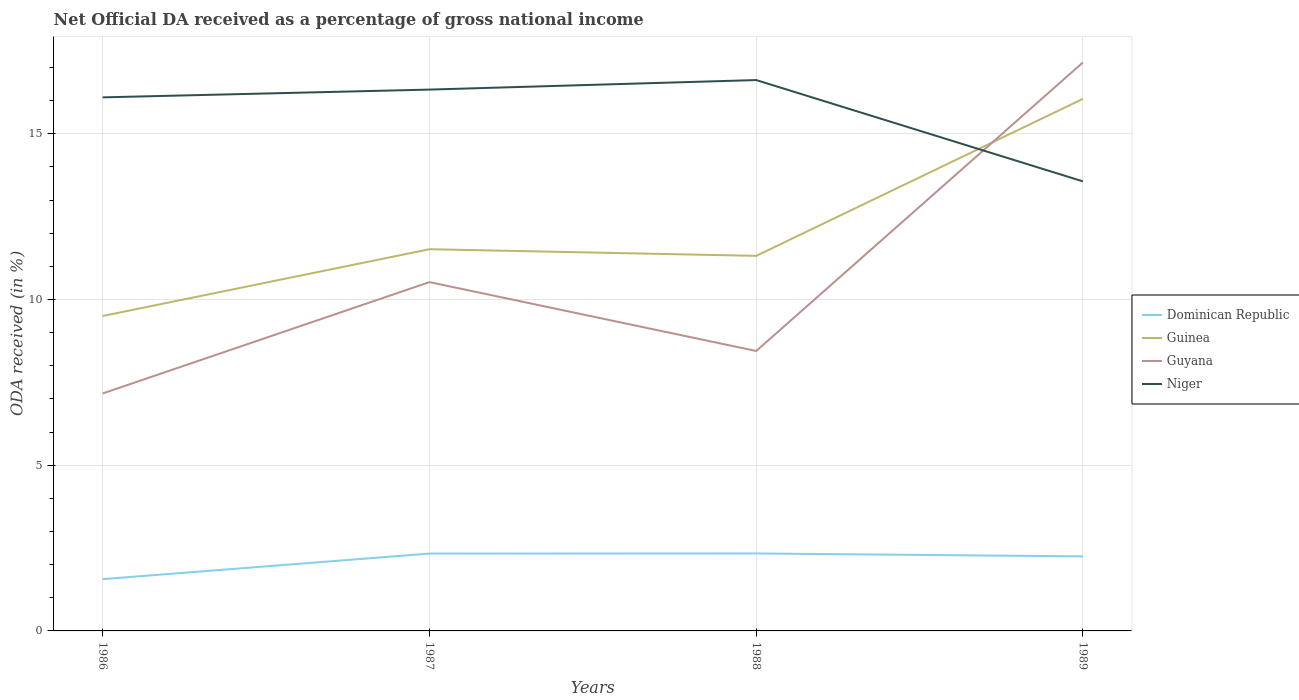How many different coloured lines are there?
Offer a very short reply. 4. Across all years, what is the maximum net official DA received in Niger?
Give a very brief answer. 13.56. In which year was the net official DA received in Guinea maximum?
Provide a succinct answer. 1986. What is the total net official DA received in Guyana in the graph?
Offer a terse response. -9.99. What is the difference between the highest and the second highest net official DA received in Niger?
Your answer should be very brief. 3.06. How many lines are there?
Keep it short and to the point. 4. What is the difference between two consecutive major ticks on the Y-axis?
Offer a very short reply. 5. Does the graph contain grids?
Offer a terse response. Yes. How many legend labels are there?
Make the answer very short. 4. What is the title of the graph?
Offer a very short reply. Net Official DA received as a percentage of gross national income. Does "Swaziland" appear as one of the legend labels in the graph?
Provide a succinct answer. No. What is the label or title of the X-axis?
Give a very brief answer. Years. What is the label or title of the Y-axis?
Your answer should be very brief. ODA received (in %). What is the ODA received (in %) in Dominican Republic in 1986?
Provide a succinct answer. 1.56. What is the ODA received (in %) of Guinea in 1986?
Provide a succinct answer. 9.5. What is the ODA received (in %) of Guyana in 1986?
Make the answer very short. 7.17. What is the ODA received (in %) in Niger in 1986?
Give a very brief answer. 16.1. What is the ODA received (in %) in Dominican Republic in 1987?
Your answer should be very brief. 2.33. What is the ODA received (in %) in Guinea in 1987?
Offer a terse response. 11.52. What is the ODA received (in %) of Guyana in 1987?
Offer a very short reply. 10.52. What is the ODA received (in %) of Niger in 1987?
Your response must be concise. 16.33. What is the ODA received (in %) of Dominican Republic in 1988?
Make the answer very short. 2.34. What is the ODA received (in %) of Guinea in 1988?
Make the answer very short. 11.32. What is the ODA received (in %) in Guyana in 1988?
Your answer should be very brief. 8.45. What is the ODA received (in %) in Niger in 1988?
Your response must be concise. 16.62. What is the ODA received (in %) of Dominican Republic in 1989?
Your response must be concise. 2.25. What is the ODA received (in %) of Guinea in 1989?
Give a very brief answer. 16.05. What is the ODA received (in %) in Guyana in 1989?
Offer a terse response. 17.15. What is the ODA received (in %) in Niger in 1989?
Your answer should be very brief. 13.56. Across all years, what is the maximum ODA received (in %) of Dominican Republic?
Your answer should be very brief. 2.34. Across all years, what is the maximum ODA received (in %) in Guinea?
Your response must be concise. 16.05. Across all years, what is the maximum ODA received (in %) of Guyana?
Provide a succinct answer. 17.15. Across all years, what is the maximum ODA received (in %) in Niger?
Provide a succinct answer. 16.62. Across all years, what is the minimum ODA received (in %) of Dominican Republic?
Your answer should be compact. 1.56. Across all years, what is the minimum ODA received (in %) of Guinea?
Your answer should be compact. 9.5. Across all years, what is the minimum ODA received (in %) of Guyana?
Provide a succinct answer. 7.17. Across all years, what is the minimum ODA received (in %) of Niger?
Provide a short and direct response. 13.56. What is the total ODA received (in %) in Dominican Republic in the graph?
Keep it short and to the point. 8.48. What is the total ODA received (in %) in Guinea in the graph?
Provide a succinct answer. 48.39. What is the total ODA received (in %) of Guyana in the graph?
Your answer should be very brief. 43.29. What is the total ODA received (in %) of Niger in the graph?
Ensure brevity in your answer.  62.61. What is the difference between the ODA received (in %) in Dominican Republic in 1986 and that in 1987?
Offer a very short reply. -0.77. What is the difference between the ODA received (in %) in Guinea in 1986 and that in 1987?
Your answer should be compact. -2.01. What is the difference between the ODA received (in %) of Guyana in 1986 and that in 1987?
Provide a succinct answer. -3.36. What is the difference between the ODA received (in %) of Niger in 1986 and that in 1987?
Keep it short and to the point. -0.23. What is the difference between the ODA received (in %) in Dominican Republic in 1986 and that in 1988?
Ensure brevity in your answer.  -0.78. What is the difference between the ODA received (in %) in Guinea in 1986 and that in 1988?
Provide a short and direct response. -1.81. What is the difference between the ODA received (in %) in Guyana in 1986 and that in 1988?
Provide a short and direct response. -1.28. What is the difference between the ODA received (in %) in Niger in 1986 and that in 1988?
Keep it short and to the point. -0.52. What is the difference between the ODA received (in %) of Dominican Republic in 1986 and that in 1989?
Give a very brief answer. -0.69. What is the difference between the ODA received (in %) in Guinea in 1986 and that in 1989?
Your answer should be compact. -6.55. What is the difference between the ODA received (in %) of Guyana in 1986 and that in 1989?
Offer a terse response. -9.99. What is the difference between the ODA received (in %) in Niger in 1986 and that in 1989?
Your response must be concise. 2.53. What is the difference between the ODA received (in %) of Dominican Republic in 1987 and that in 1988?
Keep it short and to the point. -0. What is the difference between the ODA received (in %) in Guinea in 1987 and that in 1988?
Provide a short and direct response. 0.2. What is the difference between the ODA received (in %) of Guyana in 1987 and that in 1988?
Your answer should be compact. 2.08. What is the difference between the ODA received (in %) in Niger in 1987 and that in 1988?
Offer a very short reply. -0.29. What is the difference between the ODA received (in %) of Dominican Republic in 1987 and that in 1989?
Your answer should be compact. 0.08. What is the difference between the ODA received (in %) of Guinea in 1987 and that in 1989?
Your answer should be compact. -4.54. What is the difference between the ODA received (in %) in Guyana in 1987 and that in 1989?
Your answer should be compact. -6.63. What is the difference between the ODA received (in %) in Niger in 1987 and that in 1989?
Your response must be concise. 2.77. What is the difference between the ODA received (in %) of Dominican Republic in 1988 and that in 1989?
Ensure brevity in your answer.  0.09. What is the difference between the ODA received (in %) in Guinea in 1988 and that in 1989?
Offer a very short reply. -4.74. What is the difference between the ODA received (in %) in Guyana in 1988 and that in 1989?
Offer a very short reply. -8.71. What is the difference between the ODA received (in %) of Niger in 1988 and that in 1989?
Your response must be concise. 3.06. What is the difference between the ODA received (in %) in Dominican Republic in 1986 and the ODA received (in %) in Guinea in 1987?
Give a very brief answer. -9.95. What is the difference between the ODA received (in %) of Dominican Republic in 1986 and the ODA received (in %) of Guyana in 1987?
Give a very brief answer. -8.96. What is the difference between the ODA received (in %) in Dominican Republic in 1986 and the ODA received (in %) in Niger in 1987?
Your answer should be very brief. -14.77. What is the difference between the ODA received (in %) of Guinea in 1986 and the ODA received (in %) of Guyana in 1987?
Keep it short and to the point. -1.02. What is the difference between the ODA received (in %) of Guinea in 1986 and the ODA received (in %) of Niger in 1987?
Ensure brevity in your answer.  -6.83. What is the difference between the ODA received (in %) in Guyana in 1986 and the ODA received (in %) in Niger in 1987?
Offer a very short reply. -9.17. What is the difference between the ODA received (in %) of Dominican Republic in 1986 and the ODA received (in %) of Guinea in 1988?
Your answer should be very brief. -9.75. What is the difference between the ODA received (in %) of Dominican Republic in 1986 and the ODA received (in %) of Guyana in 1988?
Provide a succinct answer. -6.88. What is the difference between the ODA received (in %) in Dominican Republic in 1986 and the ODA received (in %) in Niger in 1988?
Offer a very short reply. -15.06. What is the difference between the ODA received (in %) of Guinea in 1986 and the ODA received (in %) of Guyana in 1988?
Offer a very short reply. 1.06. What is the difference between the ODA received (in %) in Guinea in 1986 and the ODA received (in %) in Niger in 1988?
Ensure brevity in your answer.  -7.12. What is the difference between the ODA received (in %) in Guyana in 1986 and the ODA received (in %) in Niger in 1988?
Offer a very short reply. -9.46. What is the difference between the ODA received (in %) in Dominican Republic in 1986 and the ODA received (in %) in Guinea in 1989?
Provide a succinct answer. -14.49. What is the difference between the ODA received (in %) of Dominican Republic in 1986 and the ODA received (in %) of Guyana in 1989?
Provide a short and direct response. -15.59. What is the difference between the ODA received (in %) in Dominican Republic in 1986 and the ODA received (in %) in Niger in 1989?
Offer a very short reply. -12. What is the difference between the ODA received (in %) of Guinea in 1986 and the ODA received (in %) of Guyana in 1989?
Provide a short and direct response. -7.65. What is the difference between the ODA received (in %) of Guinea in 1986 and the ODA received (in %) of Niger in 1989?
Make the answer very short. -4.06. What is the difference between the ODA received (in %) in Guyana in 1986 and the ODA received (in %) in Niger in 1989?
Provide a short and direct response. -6.4. What is the difference between the ODA received (in %) in Dominican Republic in 1987 and the ODA received (in %) in Guinea in 1988?
Ensure brevity in your answer.  -8.98. What is the difference between the ODA received (in %) of Dominican Republic in 1987 and the ODA received (in %) of Guyana in 1988?
Make the answer very short. -6.11. What is the difference between the ODA received (in %) of Dominican Republic in 1987 and the ODA received (in %) of Niger in 1988?
Your answer should be compact. -14.29. What is the difference between the ODA received (in %) in Guinea in 1987 and the ODA received (in %) in Guyana in 1988?
Keep it short and to the point. 3.07. What is the difference between the ODA received (in %) in Guinea in 1987 and the ODA received (in %) in Niger in 1988?
Your response must be concise. -5.1. What is the difference between the ODA received (in %) of Guyana in 1987 and the ODA received (in %) of Niger in 1988?
Keep it short and to the point. -6.1. What is the difference between the ODA received (in %) in Dominican Republic in 1987 and the ODA received (in %) in Guinea in 1989?
Your response must be concise. -13.72. What is the difference between the ODA received (in %) in Dominican Republic in 1987 and the ODA received (in %) in Guyana in 1989?
Provide a succinct answer. -14.82. What is the difference between the ODA received (in %) in Dominican Republic in 1987 and the ODA received (in %) in Niger in 1989?
Your answer should be compact. -11.23. What is the difference between the ODA received (in %) in Guinea in 1987 and the ODA received (in %) in Guyana in 1989?
Your answer should be compact. -5.64. What is the difference between the ODA received (in %) of Guinea in 1987 and the ODA received (in %) of Niger in 1989?
Provide a short and direct response. -2.05. What is the difference between the ODA received (in %) in Guyana in 1987 and the ODA received (in %) in Niger in 1989?
Make the answer very short. -3.04. What is the difference between the ODA received (in %) in Dominican Republic in 1988 and the ODA received (in %) in Guinea in 1989?
Offer a terse response. -13.72. What is the difference between the ODA received (in %) of Dominican Republic in 1988 and the ODA received (in %) of Guyana in 1989?
Provide a short and direct response. -14.82. What is the difference between the ODA received (in %) in Dominican Republic in 1988 and the ODA received (in %) in Niger in 1989?
Your answer should be compact. -11.23. What is the difference between the ODA received (in %) of Guinea in 1988 and the ODA received (in %) of Guyana in 1989?
Give a very brief answer. -5.84. What is the difference between the ODA received (in %) of Guinea in 1988 and the ODA received (in %) of Niger in 1989?
Ensure brevity in your answer.  -2.25. What is the difference between the ODA received (in %) in Guyana in 1988 and the ODA received (in %) in Niger in 1989?
Make the answer very short. -5.12. What is the average ODA received (in %) of Dominican Republic per year?
Provide a short and direct response. 2.12. What is the average ODA received (in %) of Guinea per year?
Ensure brevity in your answer.  12.1. What is the average ODA received (in %) in Guyana per year?
Offer a terse response. 10.82. What is the average ODA received (in %) of Niger per year?
Provide a succinct answer. 15.65. In the year 1986, what is the difference between the ODA received (in %) of Dominican Republic and ODA received (in %) of Guinea?
Your response must be concise. -7.94. In the year 1986, what is the difference between the ODA received (in %) of Dominican Republic and ODA received (in %) of Guyana?
Give a very brief answer. -5.6. In the year 1986, what is the difference between the ODA received (in %) of Dominican Republic and ODA received (in %) of Niger?
Your answer should be compact. -14.54. In the year 1986, what is the difference between the ODA received (in %) in Guinea and ODA received (in %) in Guyana?
Your answer should be compact. 2.34. In the year 1986, what is the difference between the ODA received (in %) in Guinea and ODA received (in %) in Niger?
Make the answer very short. -6.6. In the year 1986, what is the difference between the ODA received (in %) in Guyana and ODA received (in %) in Niger?
Give a very brief answer. -8.93. In the year 1987, what is the difference between the ODA received (in %) of Dominican Republic and ODA received (in %) of Guinea?
Ensure brevity in your answer.  -9.18. In the year 1987, what is the difference between the ODA received (in %) in Dominican Republic and ODA received (in %) in Guyana?
Keep it short and to the point. -8.19. In the year 1987, what is the difference between the ODA received (in %) of Dominican Republic and ODA received (in %) of Niger?
Your answer should be very brief. -14. In the year 1987, what is the difference between the ODA received (in %) in Guinea and ODA received (in %) in Niger?
Offer a very short reply. -4.82. In the year 1987, what is the difference between the ODA received (in %) in Guyana and ODA received (in %) in Niger?
Offer a terse response. -5.81. In the year 1988, what is the difference between the ODA received (in %) of Dominican Republic and ODA received (in %) of Guinea?
Your response must be concise. -8.98. In the year 1988, what is the difference between the ODA received (in %) in Dominican Republic and ODA received (in %) in Guyana?
Give a very brief answer. -6.11. In the year 1988, what is the difference between the ODA received (in %) in Dominican Republic and ODA received (in %) in Niger?
Offer a terse response. -14.28. In the year 1988, what is the difference between the ODA received (in %) in Guinea and ODA received (in %) in Guyana?
Your answer should be compact. 2.87. In the year 1988, what is the difference between the ODA received (in %) in Guinea and ODA received (in %) in Niger?
Keep it short and to the point. -5.3. In the year 1988, what is the difference between the ODA received (in %) in Guyana and ODA received (in %) in Niger?
Your response must be concise. -8.17. In the year 1989, what is the difference between the ODA received (in %) of Dominican Republic and ODA received (in %) of Guinea?
Ensure brevity in your answer.  -13.8. In the year 1989, what is the difference between the ODA received (in %) in Dominican Republic and ODA received (in %) in Guyana?
Your answer should be compact. -14.9. In the year 1989, what is the difference between the ODA received (in %) in Dominican Republic and ODA received (in %) in Niger?
Your answer should be very brief. -11.31. In the year 1989, what is the difference between the ODA received (in %) of Guinea and ODA received (in %) of Guyana?
Offer a very short reply. -1.1. In the year 1989, what is the difference between the ODA received (in %) in Guinea and ODA received (in %) in Niger?
Provide a succinct answer. 2.49. In the year 1989, what is the difference between the ODA received (in %) of Guyana and ODA received (in %) of Niger?
Offer a terse response. 3.59. What is the ratio of the ODA received (in %) in Dominican Republic in 1986 to that in 1987?
Offer a terse response. 0.67. What is the ratio of the ODA received (in %) of Guinea in 1986 to that in 1987?
Make the answer very short. 0.83. What is the ratio of the ODA received (in %) in Guyana in 1986 to that in 1987?
Give a very brief answer. 0.68. What is the ratio of the ODA received (in %) of Niger in 1986 to that in 1987?
Provide a short and direct response. 0.99. What is the ratio of the ODA received (in %) in Dominican Republic in 1986 to that in 1988?
Provide a short and direct response. 0.67. What is the ratio of the ODA received (in %) of Guinea in 1986 to that in 1988?
Your response must be concise. 0.84. What is the ratio of the ODA received (in %) of Guyana in 1986 to that in 1988?
Your answer should be compact. 0.85. What is the ratio of the ODA received (in %) of Niger in 1986 to that in 1988?
Ensure brevity in your answer.  0.97. What is the ratio of the ODA received (in %) of Dominican Republic in 1986 to that in 1989?
Offer a terse response. 0.69. What is the ratio of the ODA received (in %) of Guinea in 1986 to that in 1989?
Offer a terse response. 0.59. What is the ratio of the ODA received (in %) in Guyana in 1986 to that in 1989?
Your answer should be compact. 0.42. What is the ratio of the ODA received (in %) of Niger in 1986 to that in 1989?
Provide a succinct answer. 1.19. What is the ratio of the ODA received (in %) of Guinea in 1987 to that in 1988?
Your answer should be compact. 1.02. What is the ratio of the ODA received (in %) of Guyana in 1987 to that in 1988?
Your answer should be compact. 1.25. What is the ratio of the ODA received (in %) of Niger in 1987 to that in 1988?
Offer a very short reply. 0.98. What is the ratio of the ODA received (in %) of Dominican Republic in 1987 to that in 1989?
Provide a short and direct response. 1.04. What is the ratio of the ODA received (in %) in Guinea in 1987 to that in 1989?
Offer a terse response. 0.72. What is the ratio of the ODA received (in %) of Guyana in 1987 to that in 1989?
Offer a very short reply. 0.61. What is the ratio of the ODA received (in %) of Niger in 1987 to that in 1989?
Make the answer very short. 1.2. What is the ratio of the ODA received (in %) in Dominican Republic in 1988 to that in 1989?
Offer a terse response. 1.04. What is the ratio of the ODA received (in %) in Guinea in 1988 to that in 1989?
Offer a terse response. 0.7. What is the ratio of the ODA received (in %) in Guyana in 1988 to that in 1989?
Ensure brevity in your answer.  0.49. What is the ratio of the ODA received (in %) in Niger in 1988 to that in 1989?
Offer a terse response. 1.23. What is the difference between the highest and the second highest ODA received (in %) of Dominican Republic?
Keep it short and to the point. 0. What is the difference between the highest and the second highest ODA received (in %) in Guinea?
Provide a short and direct response. 4.54. What is the difference between the highest and the second highest ODA received (in %) of Guyana?
Offer a very short reply. 6.63. What is the difference between the highest and the second highest ODA received (in %) of Niger?
Keep it short and to the point. 0.29. What is the difference between the highest and the lowest ODA received (in %) of Dominican Republic?
Make the answer very short. 0.78. What is the difference between the highest and the lowest ODA received (in %) of Guinea?
Offer a very short reply. 6.55. What is the difference between the highest and the lowest ODA received (in %) in Guyana?
Your answer should be very brief. 9.99. What is the difference between the highest and the lowest ODA received (in %) in Niger?
Provide a succinct answer. 3.06. 